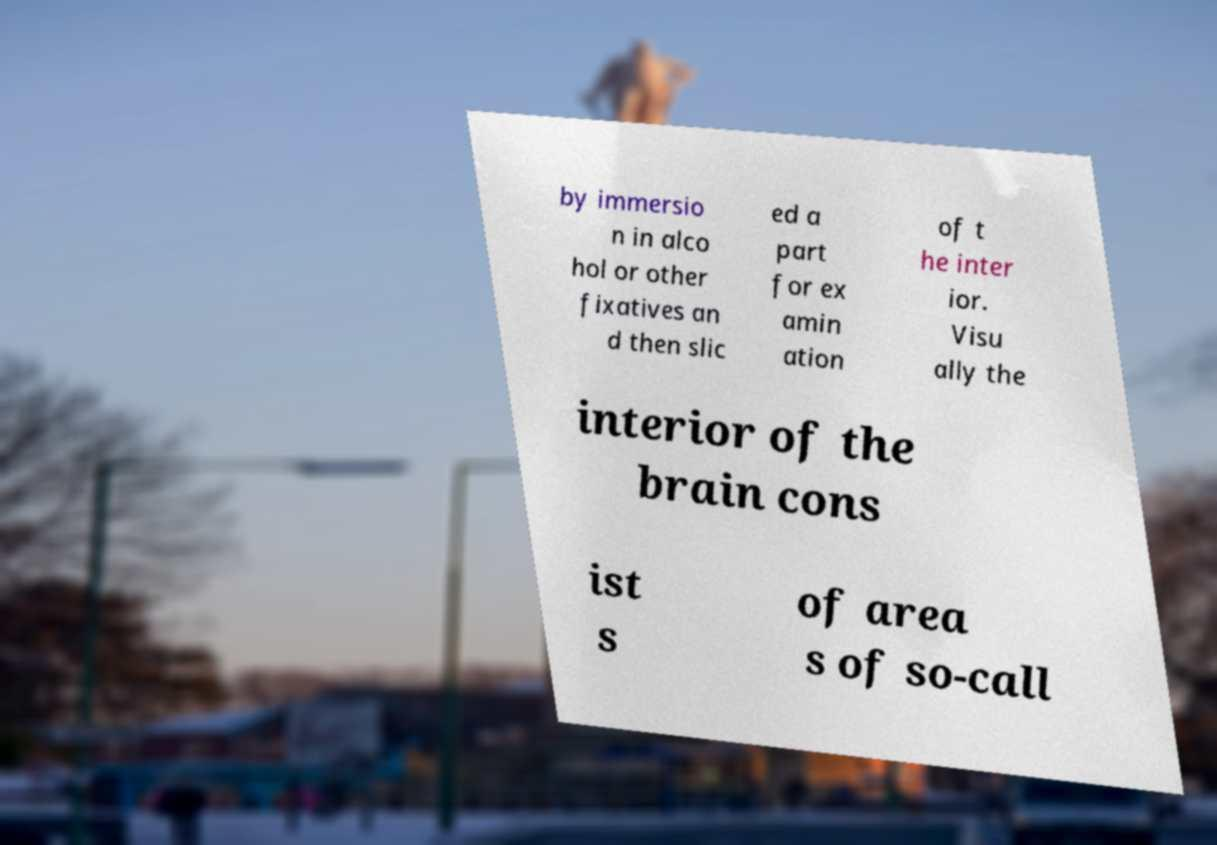For documentation purposes, I need the text within this image transcribed. Could you provide that? by immersio n in alco hol or other fixatives an d then slic ed a part for ex amin ation of t he inter ior. Visu ally the interior of the brain cons ist s of area s of so-call 